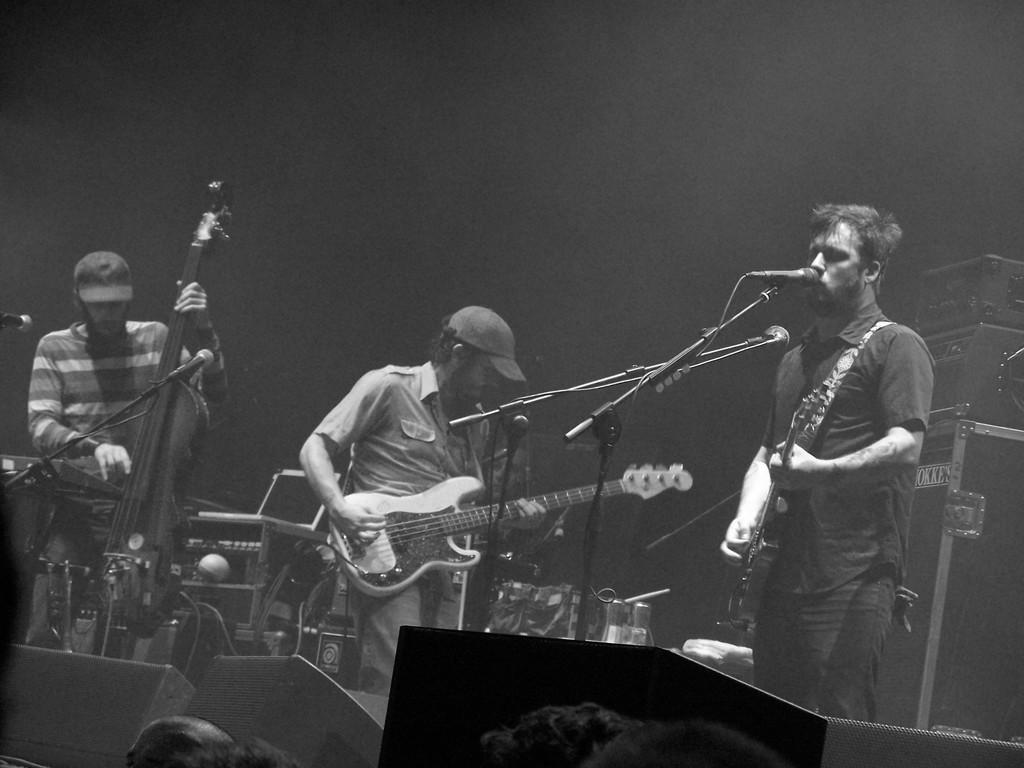What is the main subject of the image? The main subject of the image is a group of men. What are the men doing in the image? The men are standing in front of a microphone and playing musical instruments. What type of jewel can be seen on the finger of the man playing the guitar in the image? There is no jewel visible on the finger of the man playing the guitar in the image. Who is the creator of the musical instruments being played by the group of men in the image? The provided facts do not mention the creator of the musical instruments; we can only see the men playing them. 